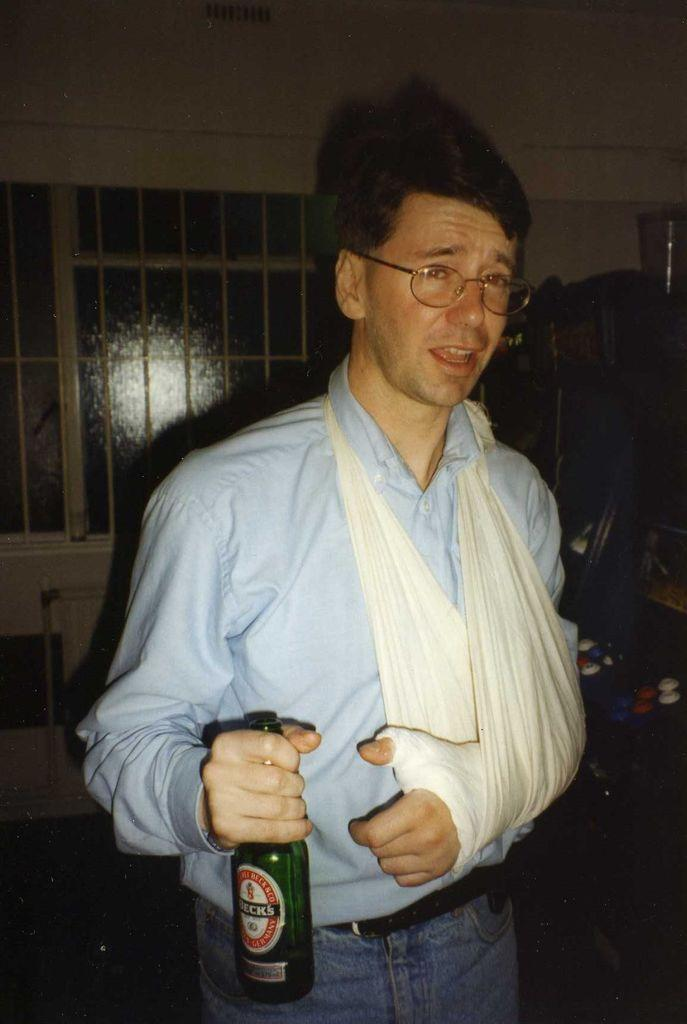What is the main subject of the image? There is a man in the image. What is the man doing in the image? The man is standing in the image. What object is the man holding in the image? The man is holding a bottle in the image. What accessory is the man wearing in the image? The man is wearing glasses (specs) in the image. What type of square-shaped boat is the man riding in the image? There is no boat present in the image, and the man is not riding anything. 